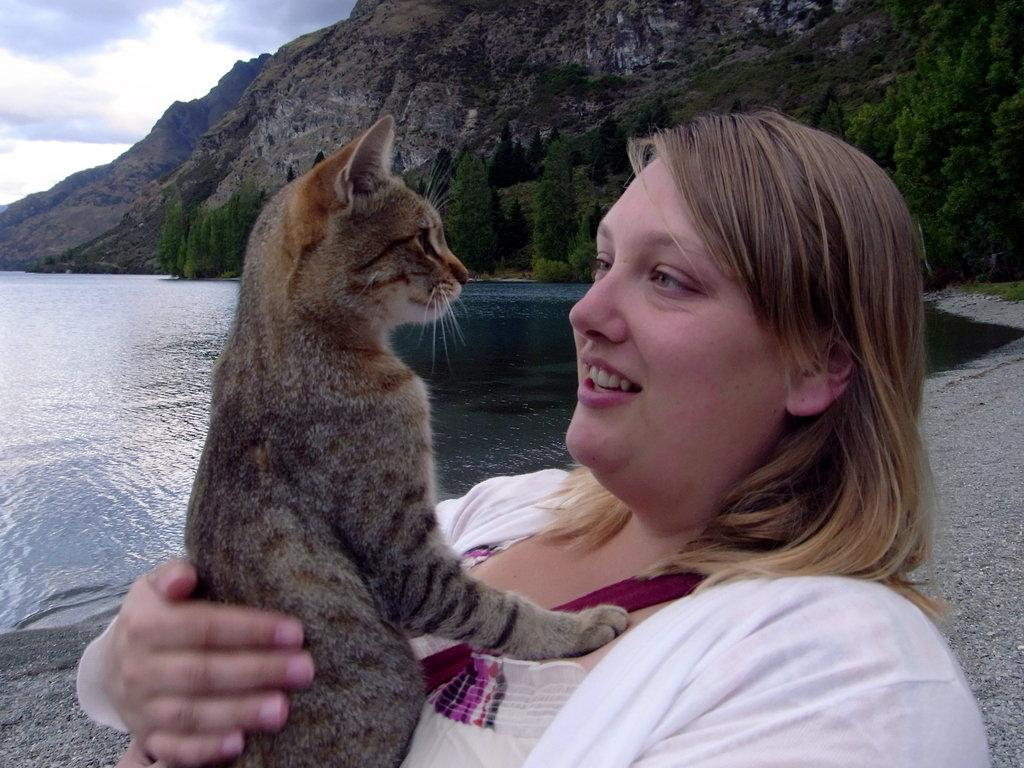Who is the main subject in the image? There is a woman in the image. What is the woman holding in the image? The woman is holding a cat. What can be seen in the background of the image? There is water, trees, and hills visible in the background of the image. What type of force is being applied to the cat in the image? There is no indication of any force being applied to the cat in the image; the woman is simply holding it. 